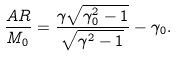<formula> <loc_0><loc_0><loc_500><loc_500>\frac { A R } { M _ { 0 } } = \frac { \gamma \sqrt { \gamma _ { 0 } ^ { 2 } - 1 } } { \sqrt { \gamma ^ { 2 } - 1 } } - \gamma _ { 0 } .</formula> 